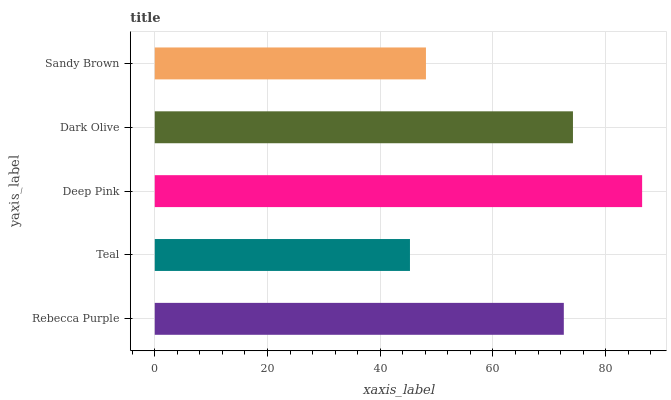Is Teal the minimum?
Answer yes or no. Yes. Is Deep Pink the maximum?
Answer yes or no. Yes. Is Deep Pink the minimum?
Answer yes or no. No. Is Teal the maximum?
Answer yes or no. No. Is Deep Pink greater than Teal?
Answer yes or no. Yes. Is Teal less than Deep Pink?
Answer yes or no. Yes. Is Teal greater than Deep Pink?
Answer yes or no. No. Is Deep Pink less than Teal?
Answer yes or no. No. Is Rebecca Purple the high median?
Answer yes or no. Yes. Is Rebecca Purple the low median?
Answer yes or no. Yes. Is Teal the high median?
Answer yes or no. No. Is Teal the low median?
Answer yes or no. No. 